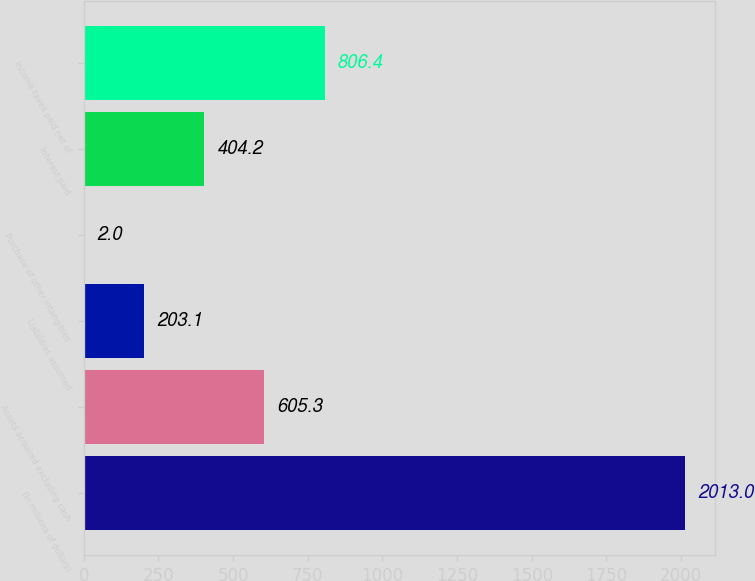Convert chart to OTSL. <chart><loc_0><loc_0><loc_500><loc_500><bar_chart><fcel>(In millions of dollars)<fcel>Assets acquired excluding cash<fcel>Liabilities assumed<fcel>Purchase of other intangibles<fcel>Interest paid<fcel>Income taxes paid net of<nl><fcel>2013<fcel>605.3<fcel>203.1<fcel>2<fcel>404.2<fcel>806.4<nl></chart> 